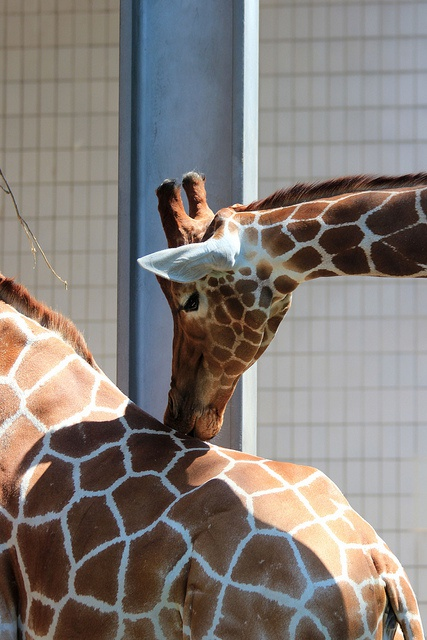Describe the objects in this image and their specific colors. I can see giraffe in gray, maroon, black, and tan tones and giraffe in gray, black, maroon, and darkgray tones in this image. 